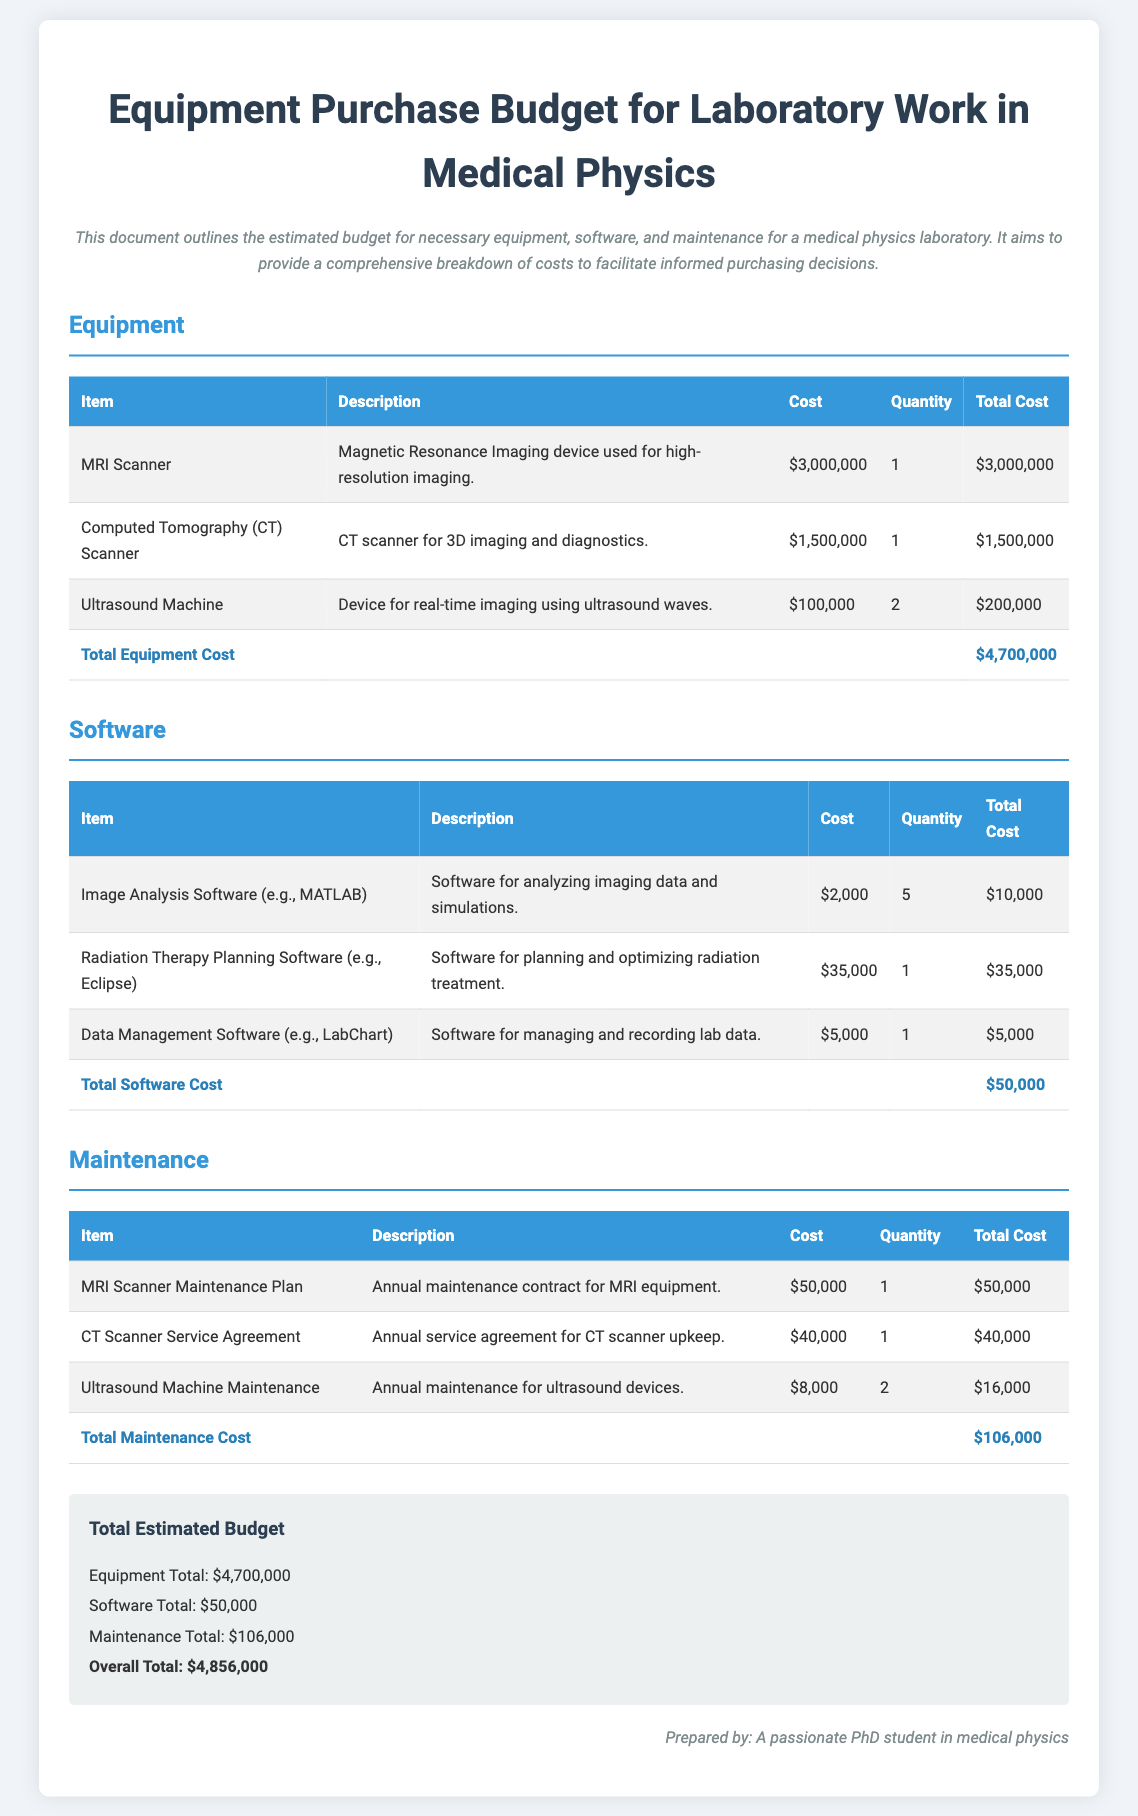What is the total equipment cost? The total equipment cost is the sum of all equipment items listed, which is $3,000,000 + $1,500,000 + $200,000.
Answer: $4,700,000 What is the cost of an MRI Scanner? The cost of the MRI Scanner is listed as $3,000,000 in the document.
Answer: $3,000,000 How many Ultrasound Machines are included in the budget? The document specifies that there are 2 Ultrasound Machines included in the budget.
Answer: 2 What is the total maintenance cost? The total maintenance cost is obtained by adding the maintenance costs for all devices, which totals $50,000 + $40,000 + $16,000.
Answer: $106,000 What is the total estimated budget for the laboratory? The total estimated budget is the sum of equipment, software, and maintenance costs, which is $4,700,000 + $50,000 + $106,000.
Answer: $4,856,000 What type of software is mentioned for imaging data? The document mentions Image Analysis Software (e.g., MATLAB) for analyzing imaging data.
Answer: Image Analysis Software (e.g., MATLAB) What is the quantity of radiation therapy planning software required? The document states that 1 unit of Radiation Therapy Planning Software (e.g., Eclipse) is required.
Answer: 1 What is the cost of the CT Scanner? The cost of the CT Scanner is detailed as $1,500,000 in the document.
Answer: $1,500,000 How many different types of maintenance contracts are detailed in the budget? The document outlines three different types of maintenance contracts for the medical devices.
Answer: 3 